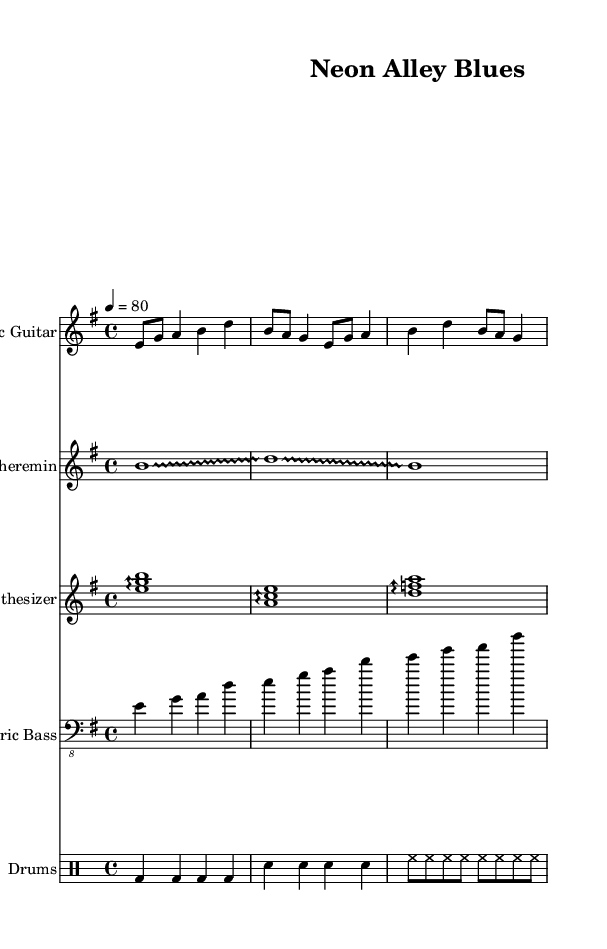What is the key signature of this music? The key signature indicated in the music sheet is E minor, which has one sharp (F#). This is identified at the beginning of the score where the key signature is specified.
Answer: E minor What is the time signature of this music? The time signature shown at the beginning of the music sheet is 4/4, which means there are four beats in each measure and the quarter note gets one beat. This is usually placed next to the key signature.
Answer: 4/4 What is the tempo marking of the music? The tempo indicated in the sheet music is "4 = 80," which tells us that each quarter note is played at a speed of 80 beats per minute. This is typically found just above the time signature in the music notation.
Answer: 80 Which instrument plays a glissando in this score? The instrument that plays a glissando is the Theremin, as noted by the technique indicated in the score. Throughout the Theremin part, "glissando" is specified, which means sliding between pitches.
Answer: Theremin How many measures does the electric guitar part contain? By counting the number of distinct segments in the electric guitar part written in the score, one can ascertain the number of measures. The electric guitar has three distinct measure patterns.
Answer: 3 What kind of technique is used in the synthesizer part? The synthesizer part utilizes arpeggio techniques as noted by the "arpeggio" marking before each chord in the score. This indicates that the notes in the chord are to be played in sequence rather than simultaneously.
Answer: Arpeggio What is the function of the drums in this piece? The drums provide a rhythmic foundation through straightforward patterns of bass and snare hits, along with hi-hat sequences, which is typical in blues music to give it a groove and support the harmonic instruments.
Answer: Rhythmic foundation 